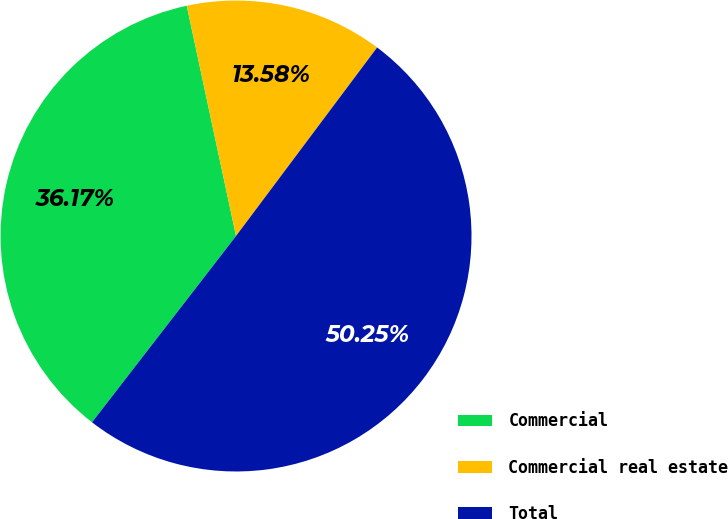Convert chart. <chart><loc_0><loc_0><loc_500><loc_500><pie_chart><fcel>Commercial<fcel>Commercial real estate<fcel>Total<nl><fcel>36.17%<fcel>13.58%<fcel>50.25%<nl></chart> 